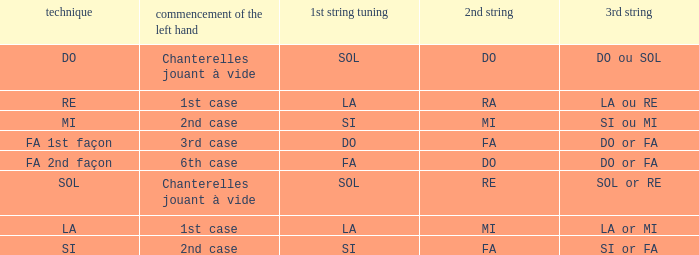What is the Depart de la main gauche of the do Mode? Chanterelles jouant à vide. 